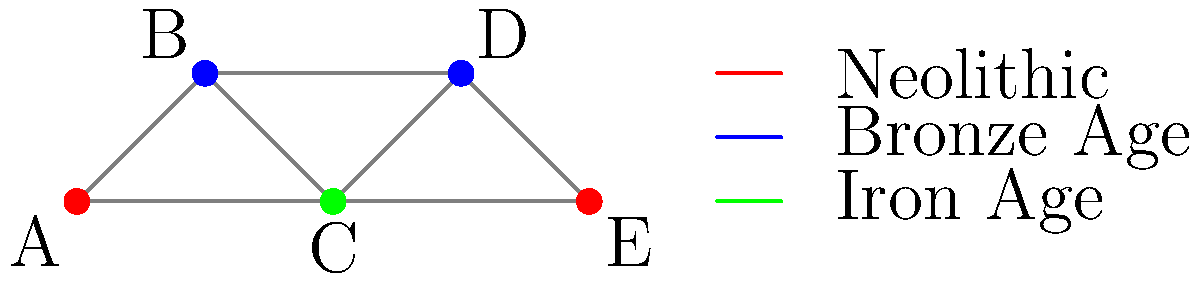In the color-coded map of archaeological sites in Somerset, how many different historical periods are represented, and what is the minimum number of colors needed to ensure no adjacent sites share the same color? To solve this question, we need to analyze the given graph and its coloring:

1. Identifying historical periods:
   - Red represents the Neolithic period
   - Blue represents the Bronze Age
   - Green represents the Iron Age
   Therefore, there are 3 different historical periods represented.

2. Determining the minimum number of colors:
   - We need to check if the current coloring is optimal (uses the minimum number of colors).
   - The graph has 5 vertices (A, B, C, D, E).
   - Vertices A and E are red, B and D are blue, and C is green.
   - No adjacent vertices share the same color.
   - We cannot reduce the number of colors to 2 because:
     a) A, C, and E form a triangle, requiring 3 colors.
     b) B, C, and D form another triangle, also requiring 3 colors.
   
Therefore, the minimum number of colors needed is 3, which matches the number of historical periods represented.
Answer: 3 periods, 3 colors 